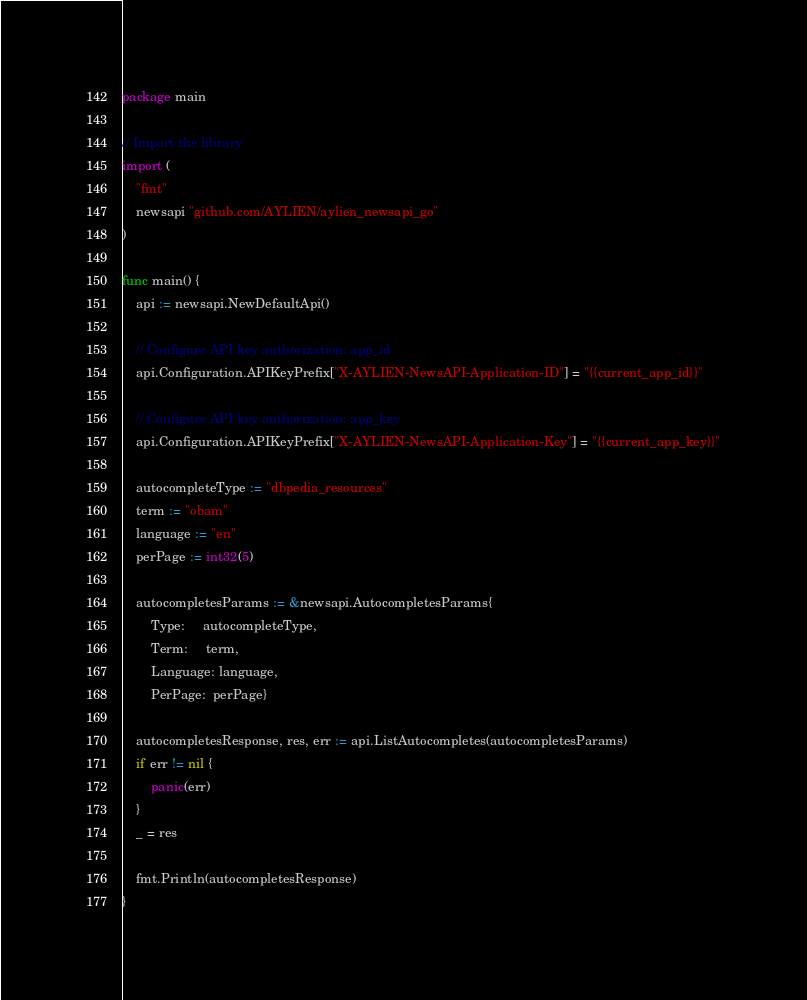Convert code to text. <code><loc_0><loc_0><loc_500><loc_500><_Go_>package main

// Import the library
import (
	"fmt"
	newsapi "github.com/AYLIEN/aylien_newsapi_go"
)

func main() {
	api := newsapi.NewDefaultApi()

	// Configure API key authorization: app_id
	api.Configuration.APIKeyPrefix["X-AYLIEN-NewsAPI-Application-ID"] = "{{current_app_id}}"

	// Configure API key authorization: app_key
	api.Configuration.APIKeyPrefix["X-AYLIEN-NewsAPI-Application-Key"] = "{{current_app_key}}"

	autocompleteType := "dbpedia_resources"
	term := "obam"
	language := "en"
	perPage := int32(5)

	autocompletesParams := &newsapi.AutocompletesParams{
		Type:     autocompleteType,
		Term:     term,
		Language: language,
		PerPage:  perPage}

	autocompletesResponse, res, err := api.ListAutocompletes(autocompletesParams)
	if err != nil {
		panic(err)
	}
	_ = res

	fmt.Println(autocompletesResponse)
}
</code> 